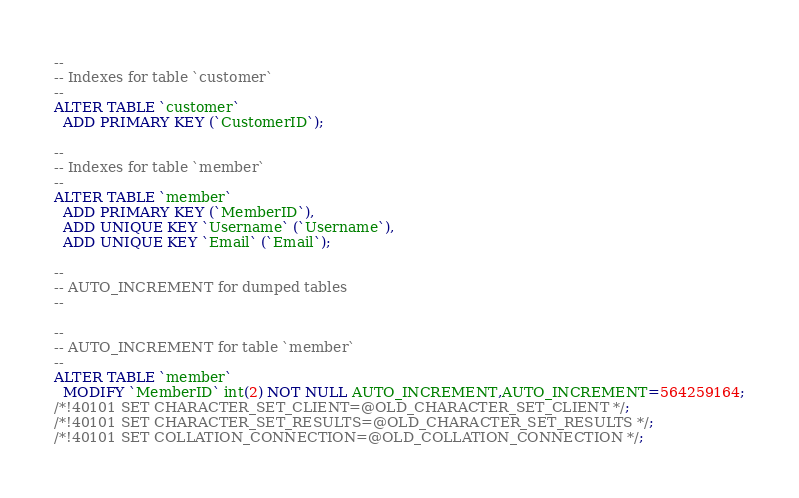<code> <loc_0><loc_0><loc_500><loc_500><_SQL_>--
-- Indexes for table `customer`
--
ALTER TABLE `customer`
  ADD PRIMARY KEY (`CustomerID`);

--
-- Indexes for table `member`
--
ALTER TABLE `member`
  ADD PRIMARY KEY (`MemberID`),
  ADD UNIQUE KEY `Username` (`Username`),
  ADD UNIQUE KEY `Email` (`Email`);

--
-- AUTO_INCREMENT for dumped tables
--

--
-- AUTO_INCREMENT for table `member`
--
ALTER TABLE `member`
  MODIFY `MemberID` int(2) NOT NULL AUTO_INCREMENT,AUTO_INCREMENT=564259164;
/*!40101 SET CHARACTER_SET_CLIENT=@OLD_CHARACTER_SET_CLIENT */;
/*!40101 SET CHARACTER_SET_RESULTS=@OLD_CHARACTER_SET_RESULTS */;
/*!40101 SET COLLATION_CONNECTION=@OLD_COLLATION_CONNECTION */;
</code> 